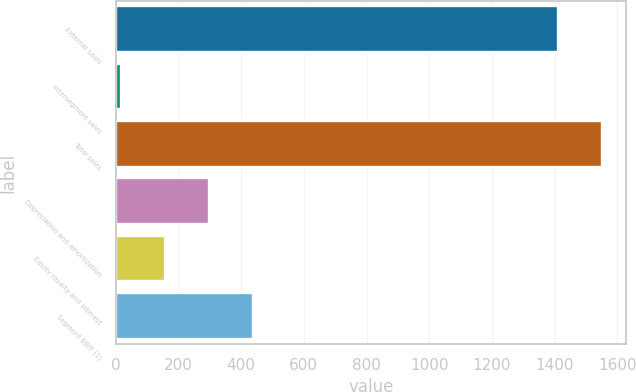Convert chart. <chart><loc_0><loc_0><loc_500><loc_500><bar_chart><fcel>External sales<fcel>Intersegment sales<fcel>Total sales<fcel>Depreciation and amortization<fcel>Equity royalty and interest<fcel>Segment EBIT (1)<nl><fcel>1409<fcel>16<fcel>1549.9<fcel>297.8<fcel>156.9<fcel>438.7<nl></chart> 